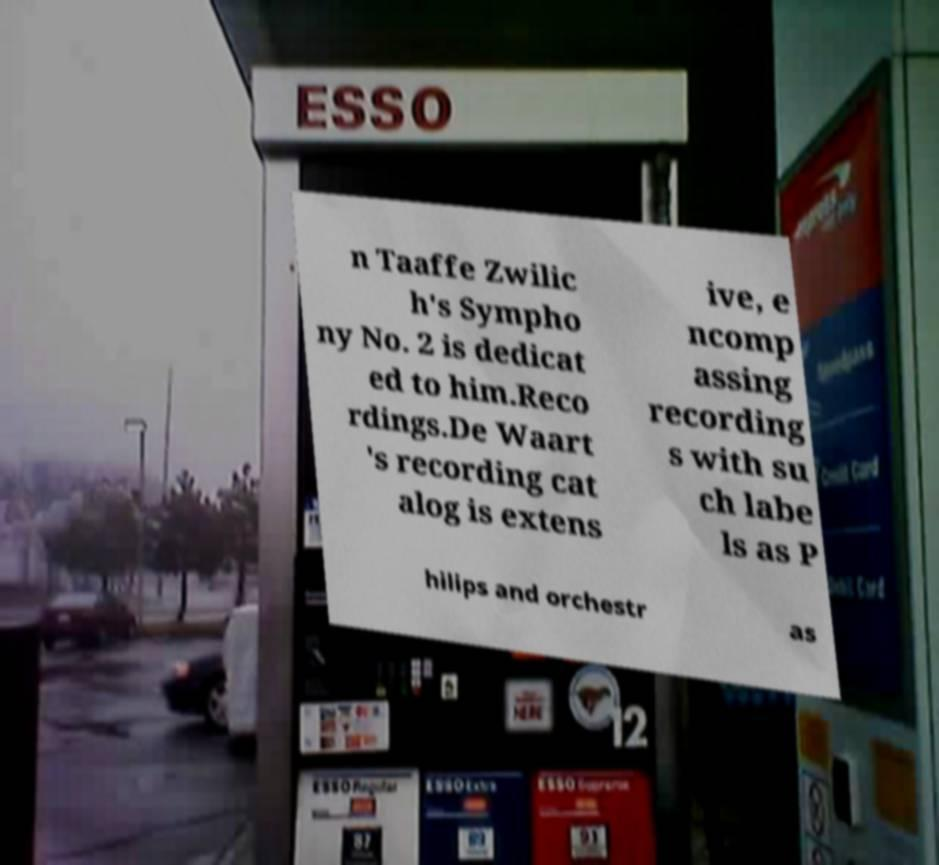Could you extract and type out the text from this image? n Taaffe Zwilic h's Sympho ny No. 2 is dedicat ed to him.Reco rdings.De Waart 's recording cat alog is extens ive, e ncomp assing recording s with su ch labe ls as P hilips and orchestr as 